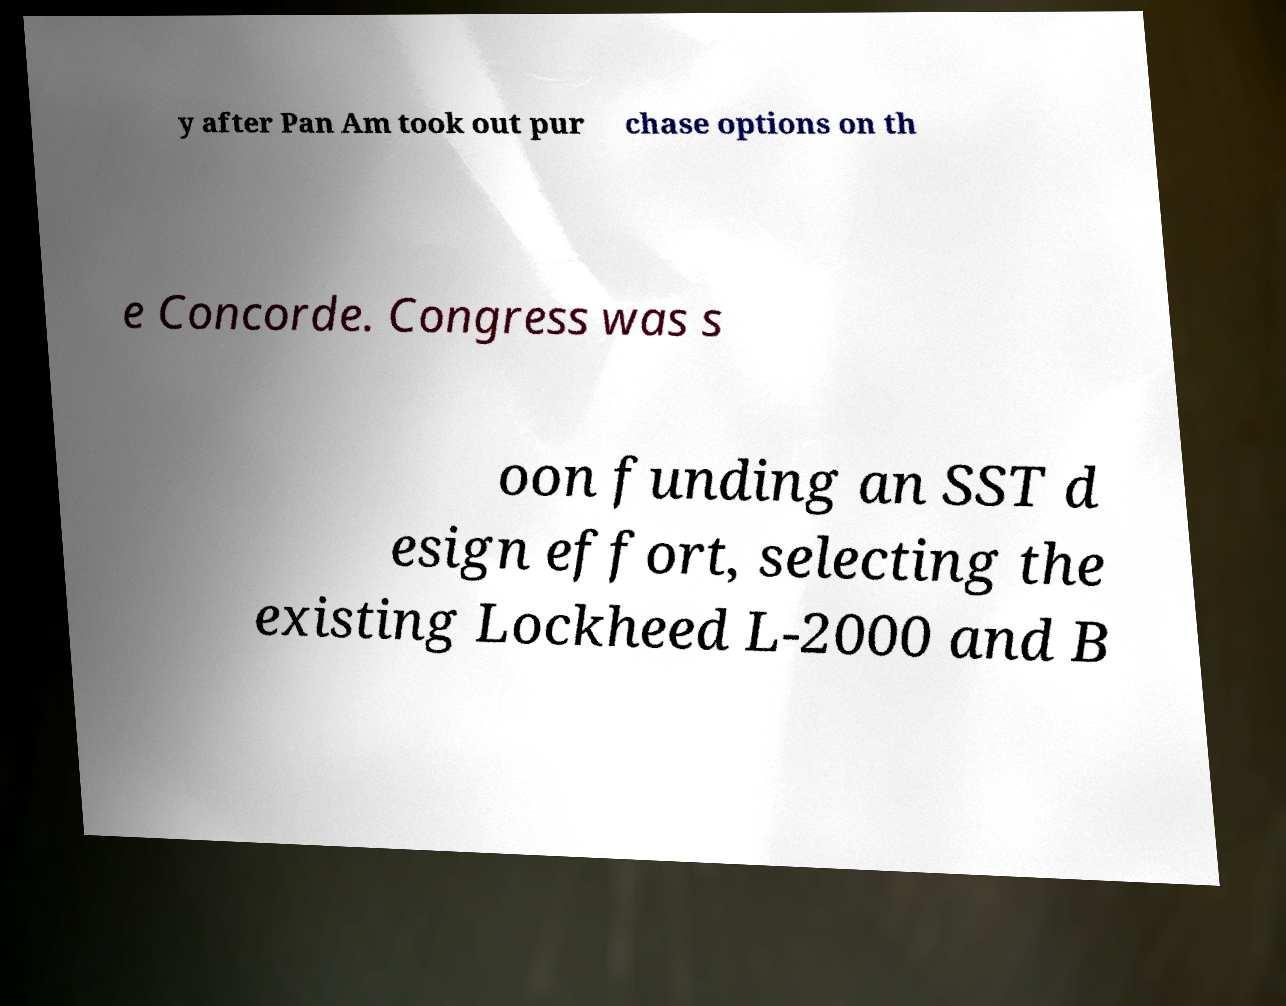Could you assist in decoding the text presented in this image and type it out clearly? y after Pan Am took out pur chase options on th e Concorde. Congress was s oon funding an SST d esign effort, selecting the existing Lockheed L-2000 and B 